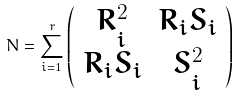<formula> <loc_0><loc_0><loc_500><loc_500>N = \sum _ { i = 1 } ^ { r } \left ( \begin{array} { c c } R _ { i } ^ { 2 } & R _ { i } S _ { i } \\ R _ { i } S _ { i } & S _ { i } ^ { 2 } \end{array} \right )</formula> 